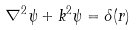<formula> <loc_0><loc_0><loc_500><loc_500>\nabla ^ { 2 } \psi + k ^ { 2 } \psi = \delta ( r )</formula> 